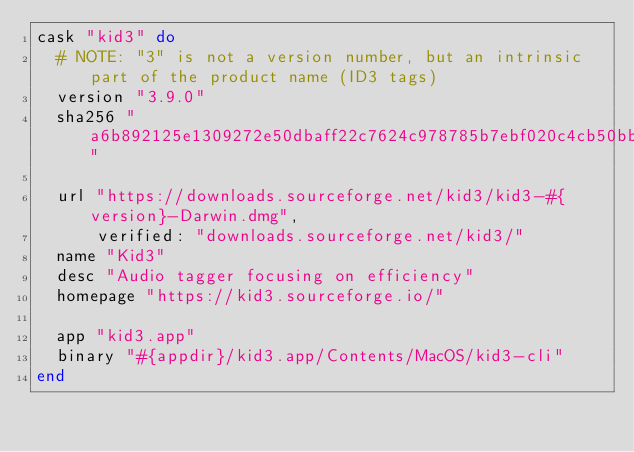<code> <loc_0><loc_0><loc_500><loc_500><_Ruby_>cask "kid3" do
  # NOTE: "3" is not a version number, but an intrinsic part of the product name (ID3 tags)
  version "3.9.0"
  sha256 "a6b892125e1309272e50dbaff22c7624c978785b7ebf020c4cb50bb556b9c9f9"

  url "https://downloads.sourceforge.net/kid3/kid3-#{version}-Darwin.dmg",
      verified: "downloads.sourceforge.net/kid3/"
  name "Kid3"
  desc "Audio tagger focusing on efficiency"
  homepage "https://kid3.sourceforge.io/"

  app "kid3.app"
  binary "#{appdir}/kid3.app/Contents/MacOS/kid3-cli"
end
</code> 